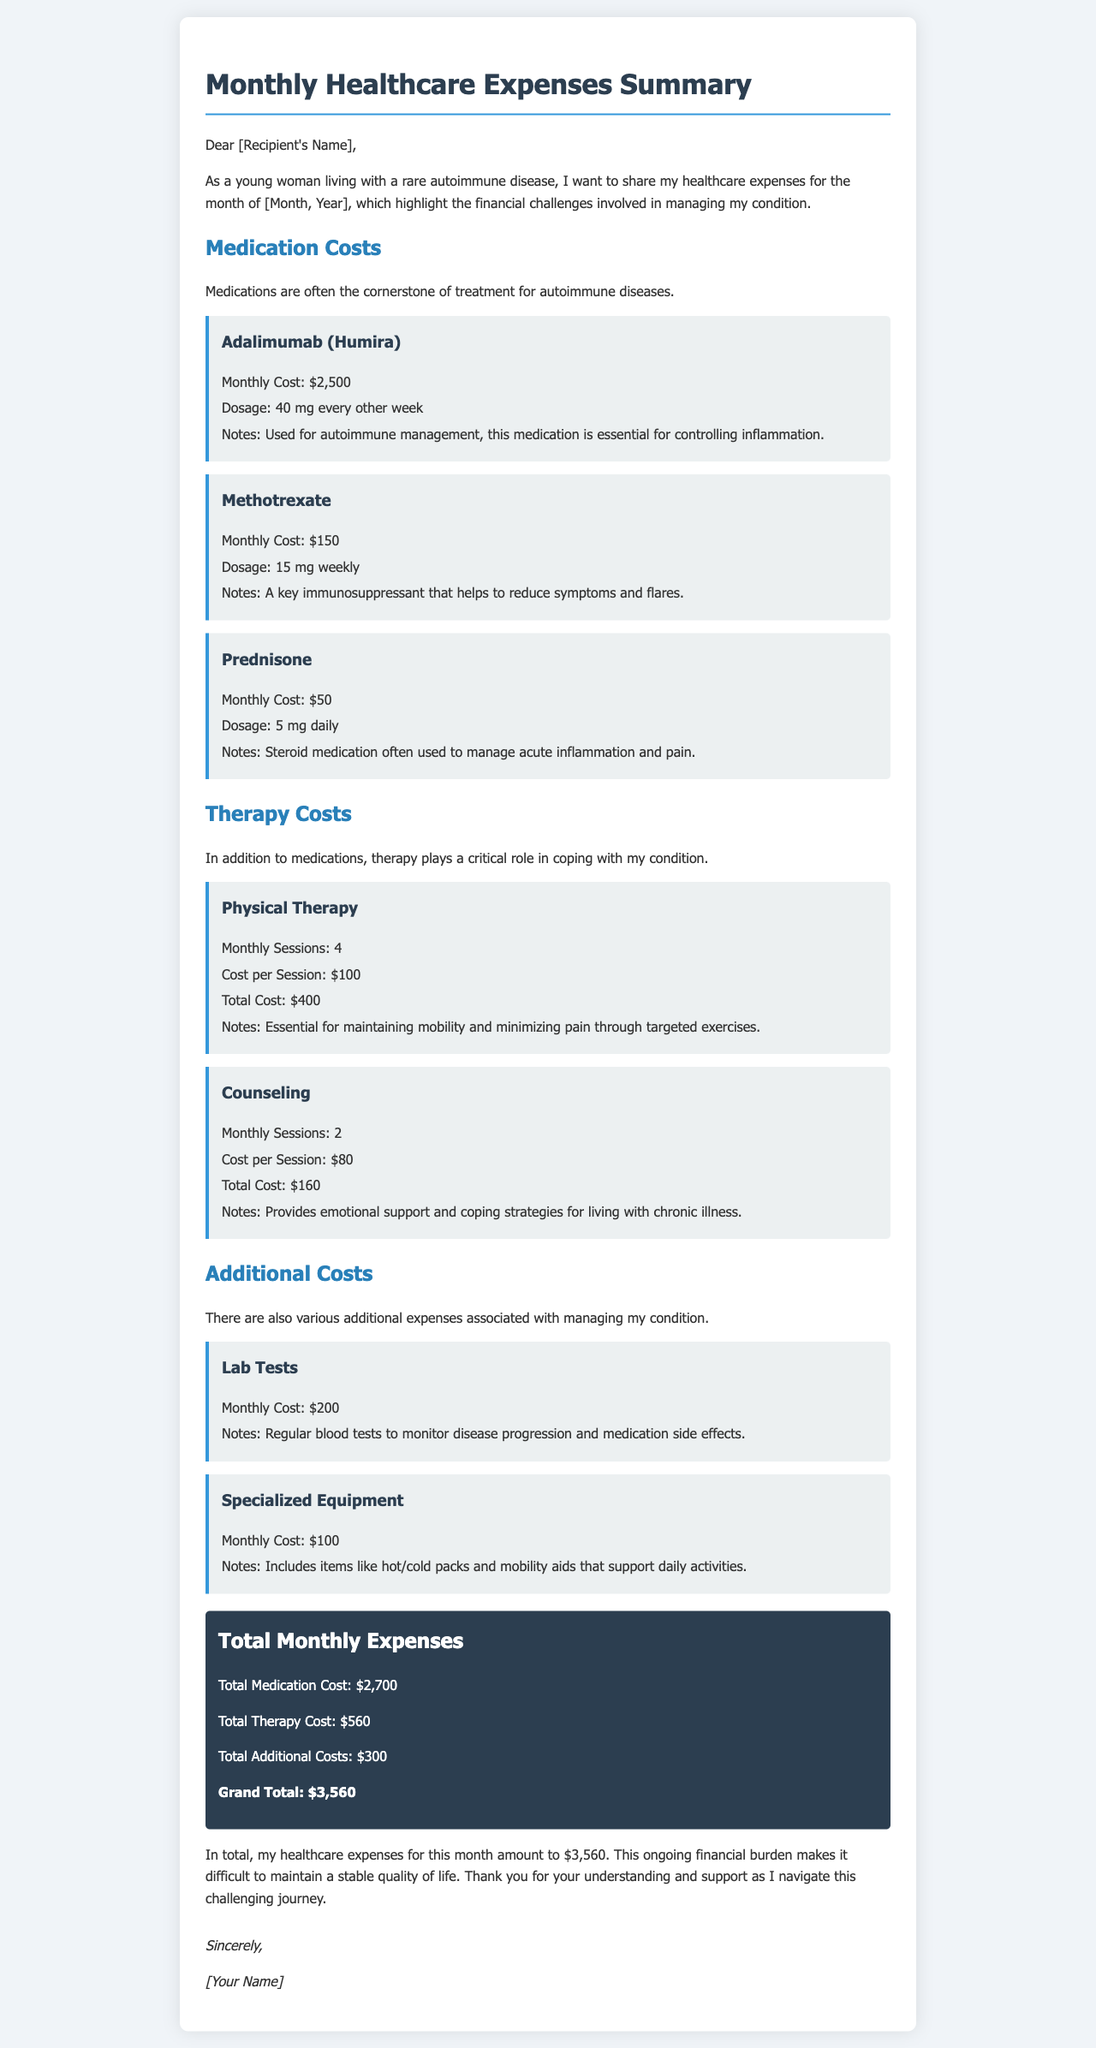What is the month and year referenced in the document? The month and year are placeholders in the document, which should be replaced with actual values when sent, therefore, it would be the specified month and year.
Answer: [Month, Year] What is the cost of Adalimumab (Humira) per month? The document specifies that the monthly cost for Adalimumab (Humira) is $2,500.
Answer: $2,500 How many sessions of Physical Therapy are mentioned per month? The document states that there are 4 Monthly Sessions of Physical Therapy.
Answer: 4 What is the total therapy cost for the month? The total therapy cost is calculated by adding the therapy expenses together, which results in $560.
Answer: $560 What is the grand total of monthly healthcare expenses? The grand total is the overall sum of all expenses detailed within the document.
Answer: $3,560 What medication is used for managing acute inflammation? The document indicates that Prednisone is frequently used for this purpose.
Answer: Prednisone How much does Counseling cost per session? According to the document, each Counseling session costs $80.
Answer: $80 What is the monthly cost of Lab Tests? The document states that the monthly cost of Lab Tests is $200.
Answer: $200 Why is Physical Therapy essential according to the document? It mentions that Physical Therapy is vital for maintaining mobility and relieving pain through targeted exercises.
Answer: Maintaining mobility and minimizing pain 